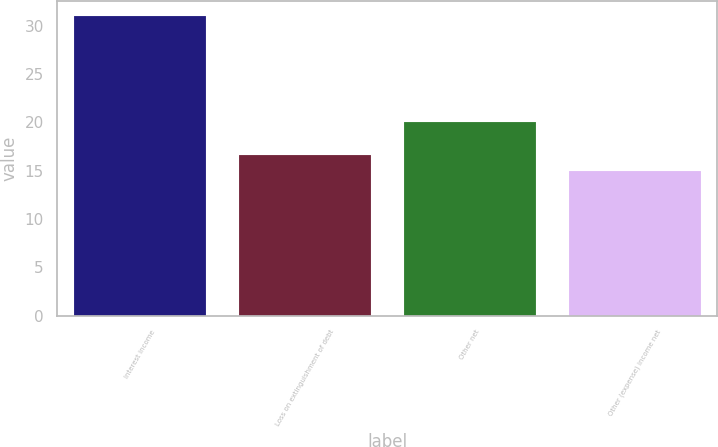Convert chart. <chart><loc_0><loc_0><loc_500><loc_500><bar_chart><fcel>Interest income<fcel>Loss on extinguishment of debt<fcel>Other net<fcel>Other (expense) income net<nl><fcel>31<fcel>16.6<fcel>20<fcel>15<nl></chart> 